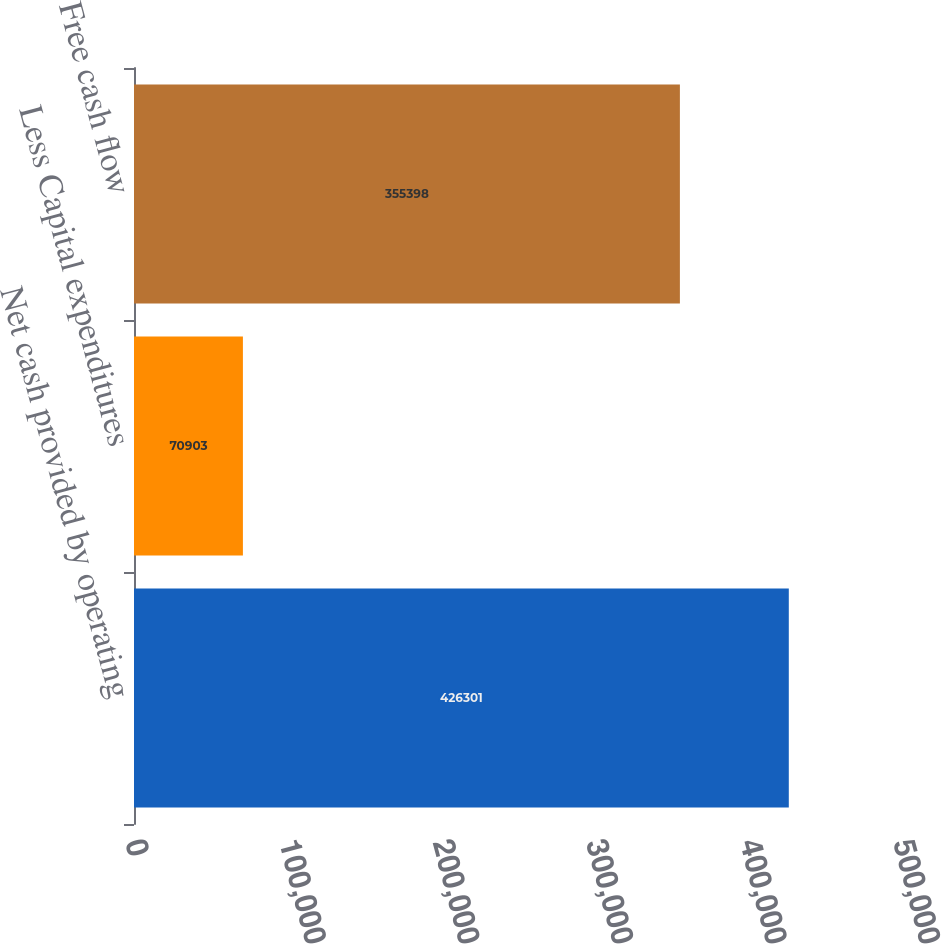Convert chart to OTSL. <chart><loc_0><loc_0><loc_500><loc_500><bar_chart><fcel>Net cash provided by operating<fcel>Less Capital expenditures<fcel>Free cash flow<nl><fcel>426301<fcel>70903<fcel>355398<nl></chart> 